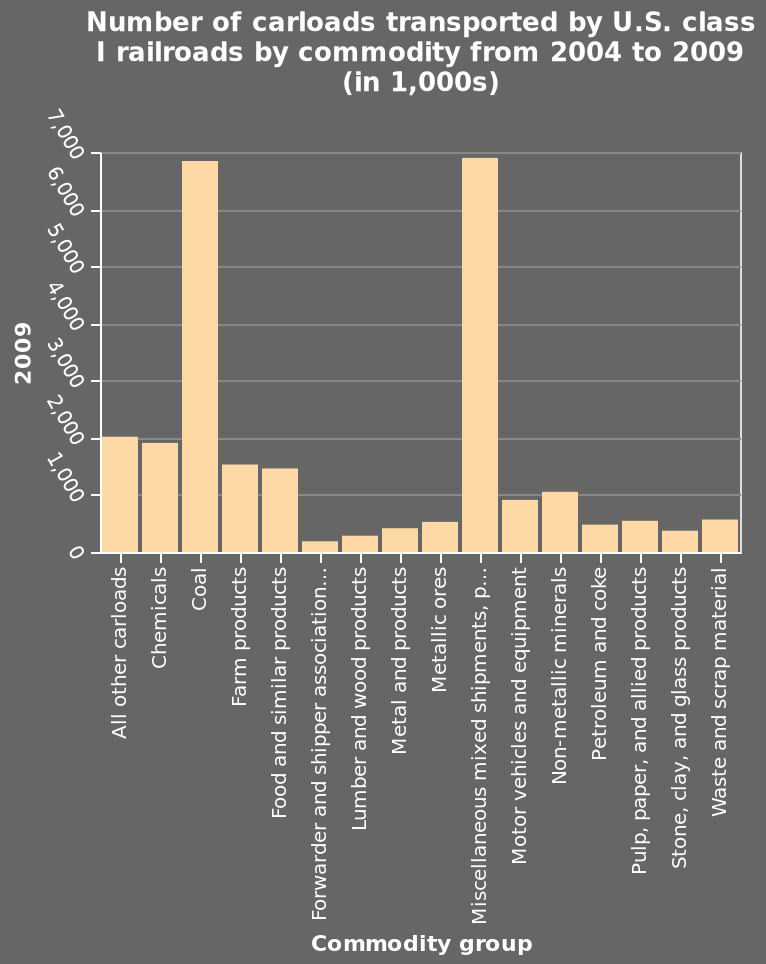<image>
What was the transportation trend for coal and miscellaneous items in 2009? They were the most transported items. What is being measured on the y-axis of the bar chart?  The y-axis of the bar chart measures the number of carloads transported by U.S. class I railroads in 2009 (in 1,000s). What does the term "carloads" refer to in the figure? In the figure, the term "carloads" refers to the number of cars transported by U.S. class I railroads. How are the values on the y-axis represented in the bar chart? The values on the y-axis of the bar chart are represented in thousands (1,000s). please enumerates aspects of the construction of the chart Number of carloads transported by U.S. class I railroads by commodity from 2004 to 2009 (in 1,000s) is a bar chart. The y-axis measures 2009. Along the x-axis, Commodity group is plotted. 